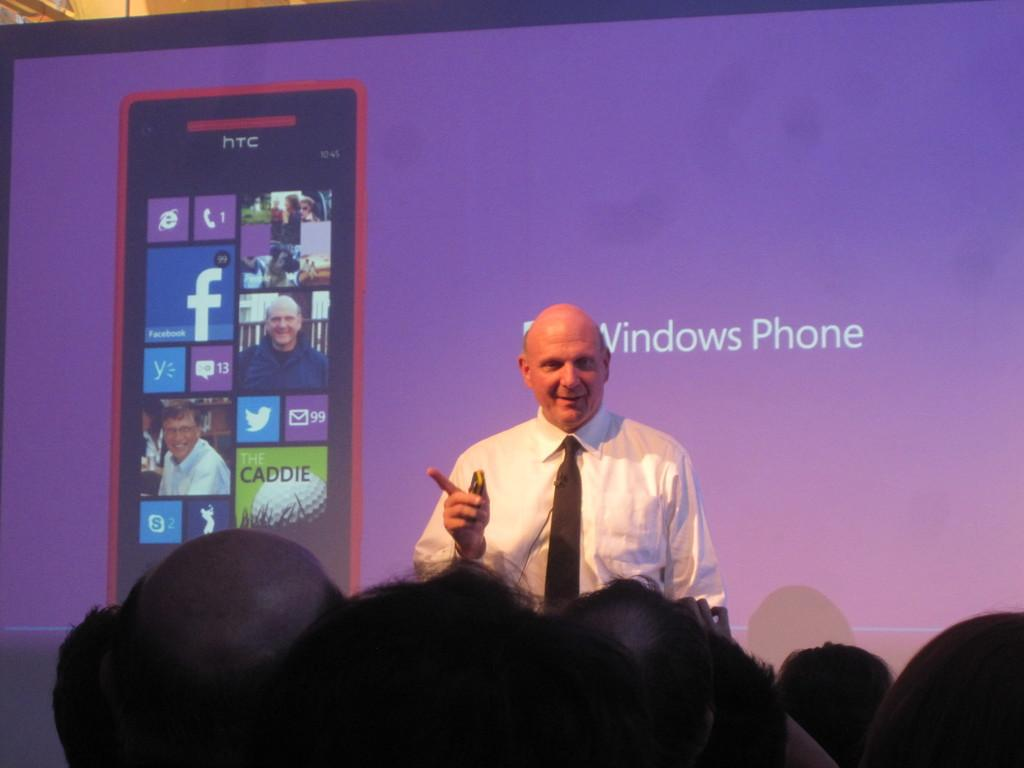<image>
Give a short and clear explanation of the subsequent image. An old bald guy in front of people discussing about a Windows Phone. 